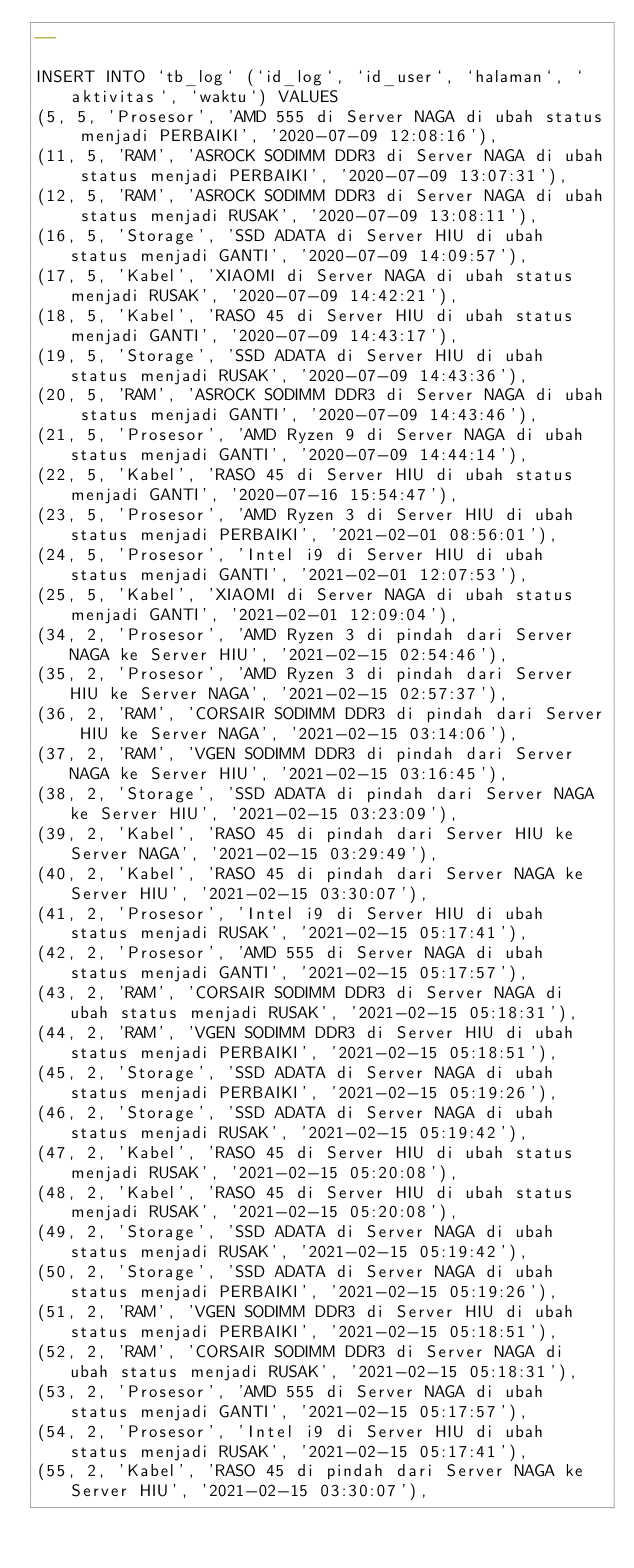Convert code to text. <code><loc_0><loc_0><loc_500><loc_500><_SQL_>--

INSERT INTO `tb_log` (`id_log`, `id_user`, `halaman`, `aktivitas`, `waktu`) VALUES
(5, 5, 'Prosesor', 'AMD 555 di Server NAGA di ubah status menjadi PERBAIKI', '2020-07-09 12:08:16'),
(11, 5, 'RAM', 'ASROCK SODIMM DDR3 di Server NAGA di ubah status menjadi PERBAIKI', '2020-07-09 13:07:31'),
(12, 5, 'RAM', 'ASROCK SODIMM DDR3 di Server NAGA di ubah status menjadi RUSAK', '2020-07-09 13:08:11'),
(16, 5, 'Storage', 'SSD ADATA di Server HIU di ubah status menjadi GANTI', '2020-07-09 14:09:57'),
(17, 5, 'Kabel', 'XIAOMI di Server NAGA di ubah status menjadi RUSAK', '2020-07-09 14:42:21'),
(18, 5, 'Kabel', 'RASO 45 di Server HIU di ubah status menjadi GANTI', '2020-07-09 14:43:17'),
(19, 5, 'Storage', 'SSD ADATA di Server HIU di ubah status menjadi RUSAK', '2020-07-09 14:43:36'),
(20, 5, 'RAM', 'ASROCK SODIMM DDR3 di Server NAGA di ubah status menjadi GANTI', '2020-07-09 14:43:46'),
(21, 5, 'Prosesor', 'AMD Ryzen 9 di Server NAGA di ubah status menjadi GANTI', '2020-07-09 14:44:14'),
(22, 5, 'Kabel', 'RASO 45 di Server HIU di ubah status menjadi GANTI', '2020-07-16 15:54:47'),
(23, 5, 'Prosesor', 'AMD Ryzen 3 di Server HIU di ubah status menjadi PERBAIKI', '2021-02-01 08:56:01'),
(24, 5, 'Prosesor', 'Intel i9 di Server HIU di ubah status menjadi GANTI', '2021-02-01 12:07:53'),
(25, 5, 'Kabel', 'XIAOMI di Server NAGA di ubah status menjadi GANTI', '2021-02-01 12:09:04'),
(34, 2, 'Prosesor', 'AMD Ryzen 3 di pindah dari Server NAGA ke Server HIU', '2021-02-15 02:54:46'),
(35, 2, 'Prosesor', 'AMD Ryzen 3 di pindah dari Server HIU ke Server NAGA', '2021-02-15 02:57:37'),
(36, 2, 'RAM', 'CORSAIR SODIMM DDR3 di pindah dari Server HIU ke Server NAGA', '2021-02-15 03:14:06'),
(37, 2, 'RAM', 'VGEN SODIMM DDR3 di pindah dari Server NAGA ke Server HIU', '2021-02-15 03:16:45'),
(38, 2, 'Storage', 'SSD ADATA di pindah dari Server NAGA ke Server HIU', '2021-02-15 03:23:09'),
(39, 2, 'Kabel', 'RASO 45 di pindah dari Server HIU ke Server NAGA', '2021-02-15 03:29:49'),
(40, 2, 'Kabel', 'RASO 45 di pindah dari Server NAGA ke Server HIU', '2021-02-15 03:30:07'),
(41, 2, 'Prosesor', 'Intel i9 di Server HIU di ubah status menjadi RUSAK', '2021-02-15 05:17:41'),
(42, 2, 'Prosesor', 'AMD 555 di Server NAGA di ubah status menjadi GANTI', '2021-02-15 05:17:57'),
(43, 2, 'RAM', 'CORSAIR SODIMM DDR3 di Server NAGA di ubah status menjadi RUSAK', '2021-02-15 05:18:31'),
(44, 2, 'RAM', 'VGEN SODIMM DDR3 di Server HIU di ubah status menjadi PERBAIKI', '2021-02-15 05:18:51'),
(45, 2, 'Storage', 'SSD ADATA di Server NAGA di ubah status menjadi PERBAIKI', '2021-02-15 05:19:26'),
(46, 2, 'Storage', 'SSD ADATA di Server NAGA di ubah status menjadi RUSAK', '2021-02-15 05:19:42'),
(47, 2, 'Kabel', 'RASO 45 di Server HIU di ubah status menjadi RUSAK', '2021-02-15 05:20:08'),
(48, 2, 'Kabel', 'RASO 45 di Server HIU di ubah status menjadi RUSAK', '2021-02-15 05:20:08'),
(49, 2, 'Storage', 'SSD ADATA di Server NAGA di ubah status menjadi RUSAK', '2021-02-15 05:19:42'),
(50, 2, 'Storage', 'SSD ADATA di Server NAGA di ubah status menjadi PERBAIKI', '2021-02-15 05:19:26'),
(51, 2, 'RAM', 'VGEN SODIMM DDR3 di Server HIU di ubah status menjadi PERBAIKI', '2021-02-15 05:18:51'),
(52, 2, 'RAM', 'CORSAIR SODIMM DDR3 di Server NAGA di ubah status menjadi RUSAK', '2021-02-15 05:18:31'),
(53, 2, 'Prosesor', 'AMD 555 di Server NAGA di ubah status menjadi GANTI', '2021-02-15 05:17:57'),
(54, 2, 'Prosesor', 'Intel i9 di Server HIU di ubah status menjadi RUSAK', '2021-02-15 05:17:41'),
(55, 2, 'Kabel', 'RASO 45 di pindah dari Server NAGA ke Server HIU', '2021-02-15 03:30:07'),</code> 